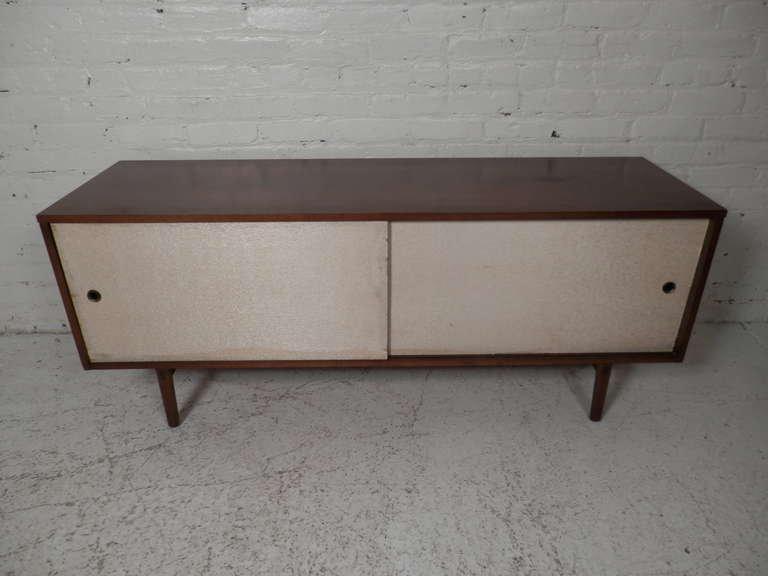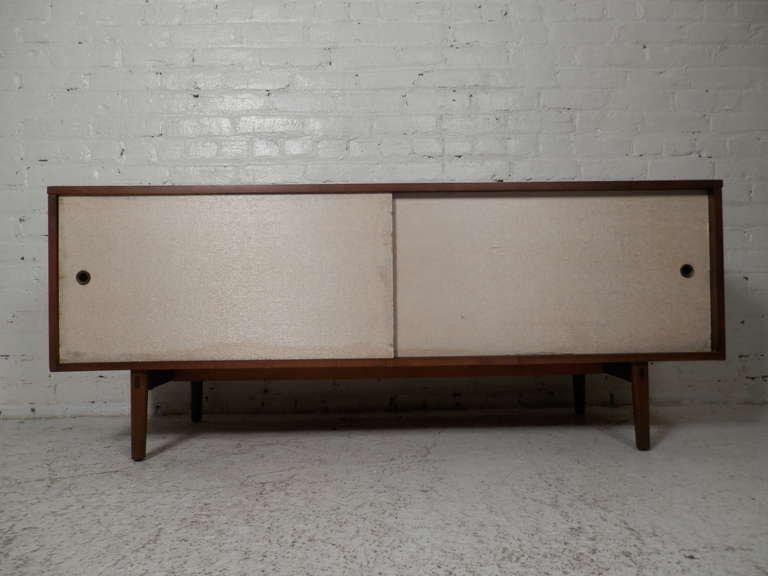The first image is the image on the left, the second image is the image on the right. Examine the images to the left and right. Is the description "Two low, wide wooden shelving units are different colors and different designs." accurate? Answer yes or no. No. The first image is the image on the left, the second image is the image on the right. Examine the images to the left and right. Is the description "In 1 of the images, 1 cabinet on a solid floor has a door opened in the front." accurate? Answer yes or no. No. 